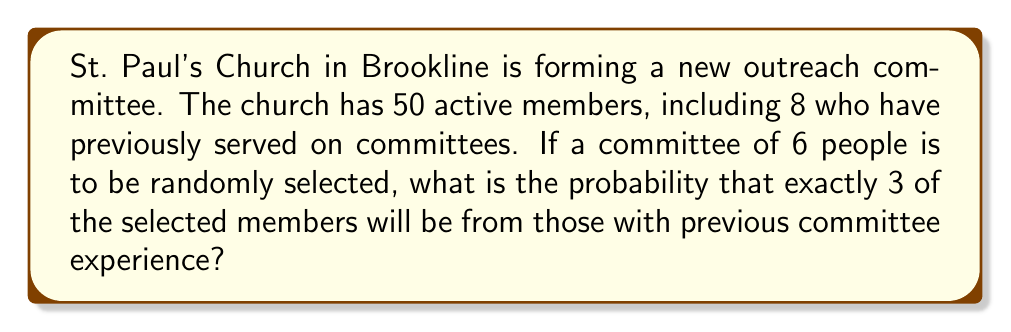Teach me how to tackle this problem. Let's approach this step-by-step:

1) First, we need to calculate the number of ways to select 3 people from the 8 experienced members. This can be done using the combination formula:

   $$\binom{8}{3} = \frac{8!}{3!(8-3)!} = \frac{8!}{3!5!} = 56$$

2) Next, we need to calculate the number of ways to select the remaining 3 people from the 42 inexperienced members:

   $$\binom{42}{3} = \frac{42!}{3!(42-3)!} = \frac{42!}{3!39!} = 11,480$$

3) The total number of ways to select 3 experienced and 3 inexperienced members is:

   $$56 \times 11,480 = 642,880$$

4) Now, we need to calculate the total number of ways to select 6 people from 50 members:

   $$\binom{50}{6} = \frac{50!}{6!(50-6)!} = \frac{50!}{6!44!} = 15,890,700$$

5) The probability is the number of favorable outcomes divided by the total number of possible outcomes:

   $$P(\text{exactly 3 experienced}) = \frac{642,880}{15,890,700} = \frac{32,144}{794,535} \approx 0.0405$$
Answer: The probability is $\frac{32,144}{794,535}$ or approximately 0.0405 (4.05%). 